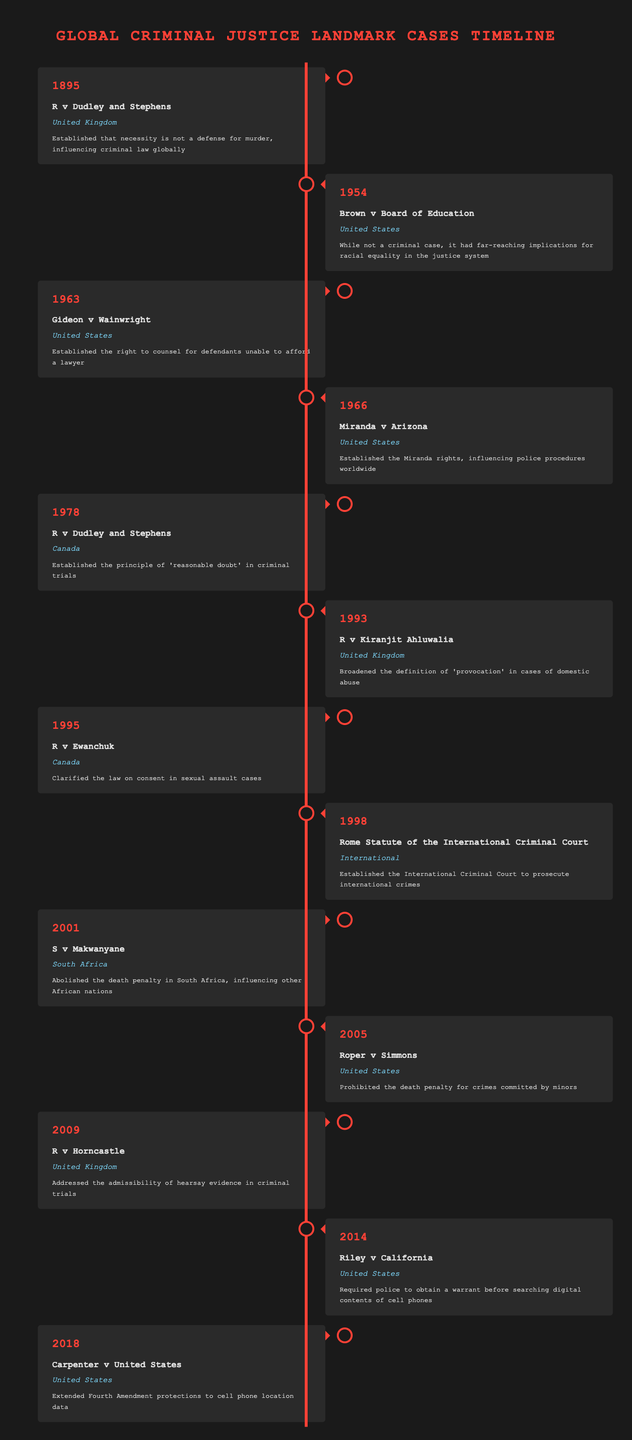What landmark legal case established the right to counsel for defendants unable to afford a lawyer? According to the table, the case "Gideon v Wainwright" from 1963 in the United States corresponds to the right to counsel for defendants who cannot afford a lawyer.
Answer: Gideon v Wainwright In which year did South Africa abolish the death penalty? From the table, the case "S v Makwanyane" in 2001 in South Africa indicates the year when the death penalty was abolished.
Answer: 2001 Which case broadened the definition of 'provocation' in domestic abuse cases? The table states that "R v Kiranjit Ahluwalia" in 1993 from the United Kingdom is significant for broadening the definition of 'provocation' in domestic abuse scenarios.
Answer: R v Kiranjit Ahluwalia How many cases mentioned in the table are from the United States? By counting the entries, we find that there are seven cases from the United States: Brown v Board of Education, Gideon v Wainwright, Miranda v Arizona, Roper v Simmons, Riley v California, Carpenter v United States.
Answer: 7 Did the Rome Statute of the International Criminal Court establish a court for prosecuting international crimes? The description for the case "Rome Statute of the International Criminal Court" from 1998 confirms that it established the International Criminal Court for this purpose.
Answer: Yes What is the significance of the Miranda rights established in 1966? The table indicates that "Miranda v Arizona" established the Miranda rights, which have influenced police procedures globally. This can be interpreted as essential for protecting the rights of individuals taken into custody.
Answer: Influenced police procedures globally Which case clarified the law on consent in sexual assault cases? From the information in the table, "R v Ewanchuk" from 1995 in Canada clarified the law on consent in sexual assault cases.
Answer: R v Ewanchuk How many years passed between the establishment of the necessity as a defense for murder in the UK and the establishment of the right to counsel in the US? The case "R v Dudley and Stephens" from 1895 does not allow necessity as a defense for murder, and "Gideon v Wainwright" established the right to counsel in 1963. The difference is 1963 - 1895 = 68 years.
Answer: 68 years What is the significance of the case "Riley v California" from 2014? According to the table, "Riley v California" required police to obtain a warrant before searching digital contents of cell phones, which reflects important advancements in privacy rights concerning digital data.
Answer: Required a warrant for digital searches 